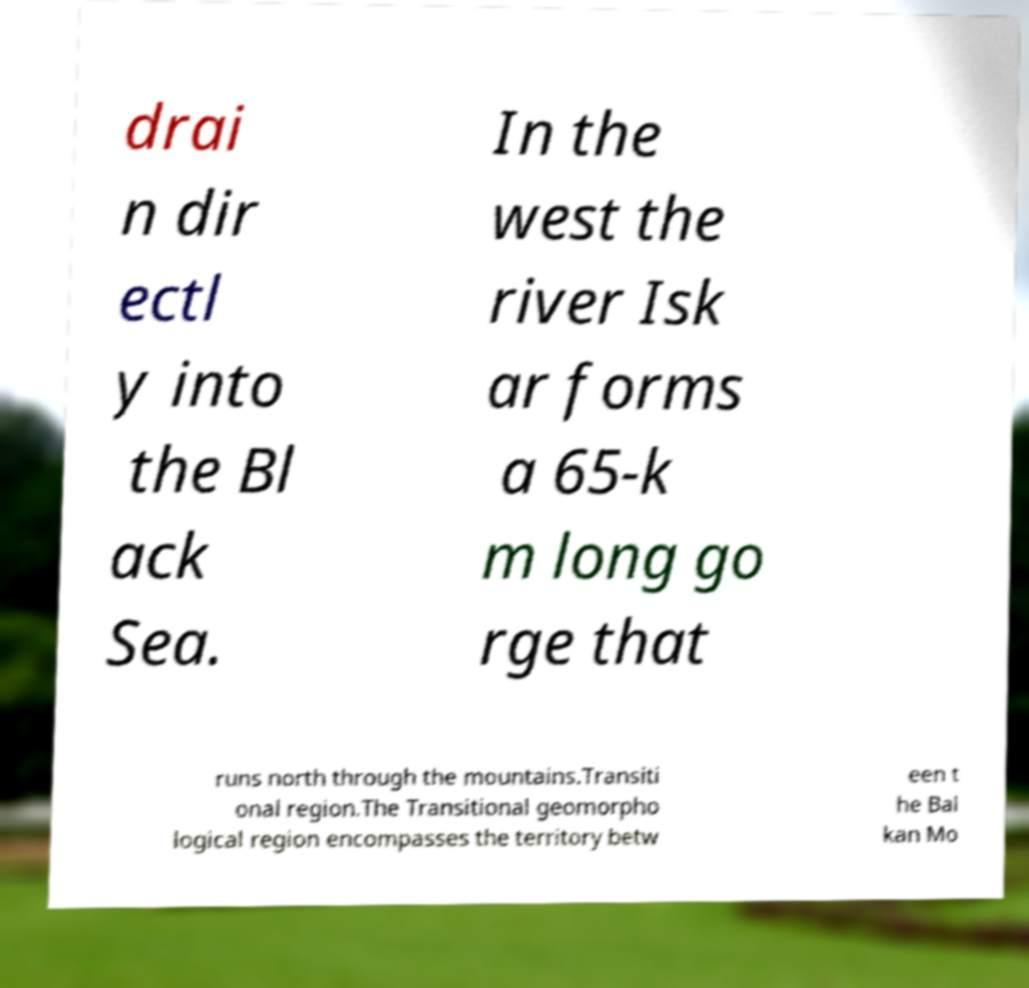Could you extract and type out the text from this image? drai n dir ectl y into the Bl ack Sea. In the west the river Isk ar forms a 65-k m long go rge that runs north through the mountains.Transiti onal region.The Transitional geomorpho logical region encompasses the territory betw een t he Bal kan Mo 